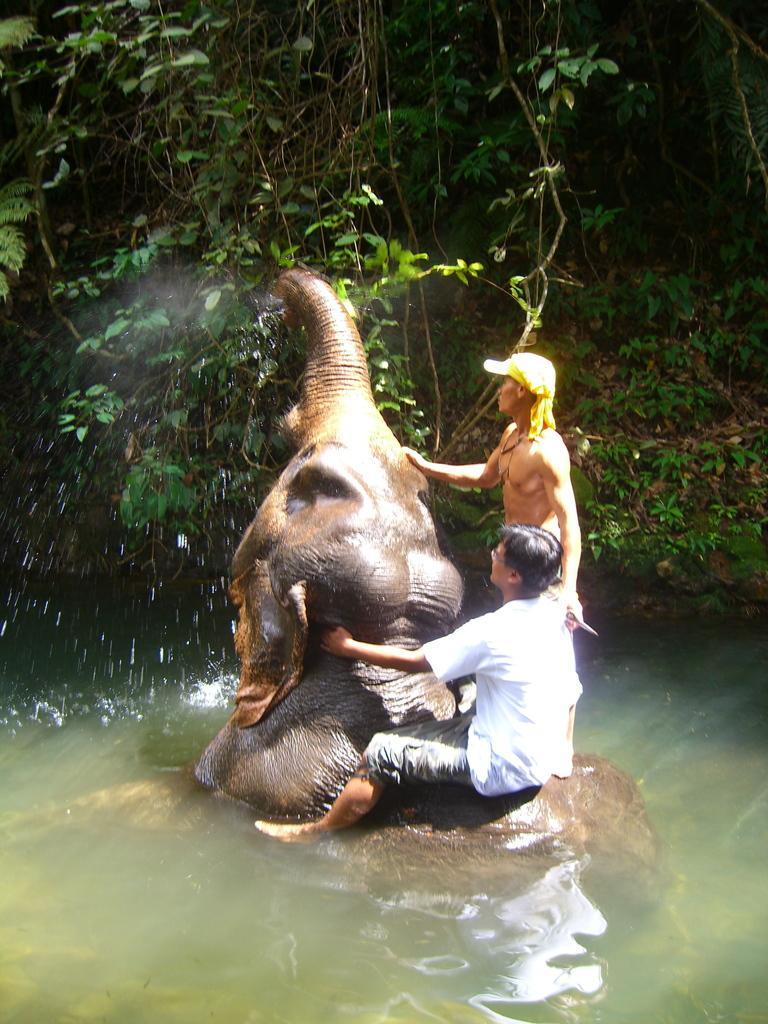How would you summarize this image in a sentence or two? In this picture a guy is sitting on an elephant which is inside the water and a guy who is holding the elephant's trunk. In the background there are trees. The image is clicked inside a forest. 